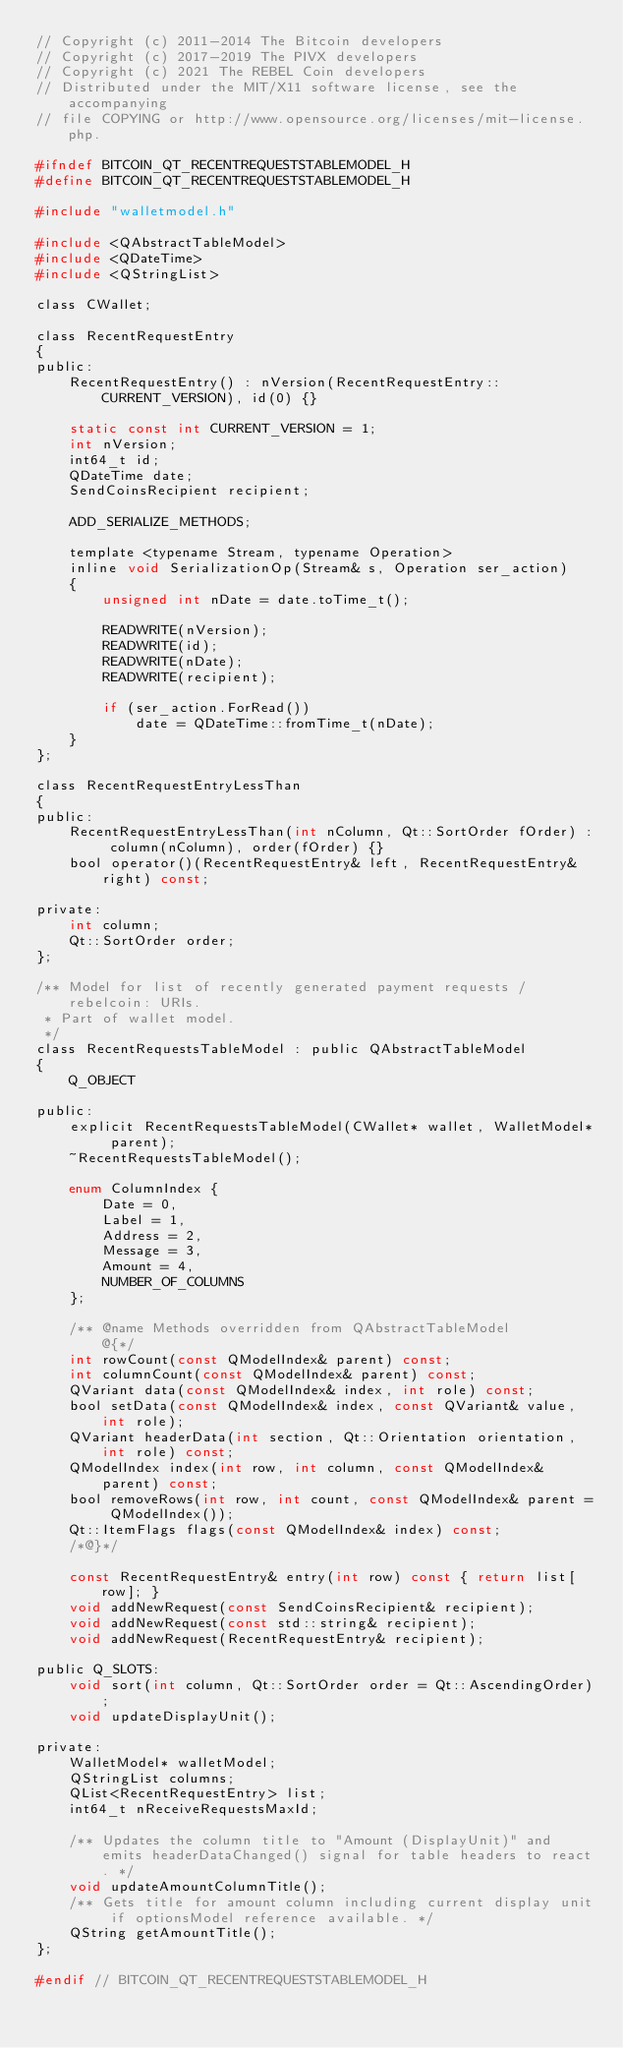Convert code to text. <code><loc_0><loc_0><loc_500><loc_500><_C_>// Copyright (c) 2011-2014 The Bitcoin developers
// Copyright (c) 2017-2019 The PIVX developers
// Copyright (c) 2021 The REBEL Coin developers
// Distributed under the MIT/X11 software license, see the accompanying
// file COPYING or http://www.opensource.org/licenses/mit-license.php.

#ifndef BITCOIN_QT_RECENTREQUESTSTABLEMODEL_H
#define BITCOIN_QT_RECENTREQUESTSTABLEMODEL_H

#include "walletmodel.h"

#include <QAbstractTableModel>
#include <QDateTime>
#include <QStringList>

class CWallet;

class RecentRequestEntry
{
public:
    RecentRequestEntry() : nVersion(RecentRequestEntry::CURRENT_VERSION), id(0) {}

    static const int CURRENT_VERSION = 1;
    int nVersion;
    int64_t id;
    QDateTime date;
    SendCoinsRecipient recipient;

    ADD_SERIALIZE_METHODS;

    template <typename Stream, typename Operation>
    inline void SerializationOp(Stream& s, Operation ser_action)
    {
        unsigned int nDate = date.toTime_t();

        READWRITE(nVersion);
        READWRITE(id);
        READWRITE(nDate);
        READWRITE(recipient);

        if (ser_action.ForRead())
            date = QDateTime::fromTime_t(nDate);
    }
};

class RecentRequestEntryLessThan
{
public:
    RecentRequestEntryLessThan(int nColumn, Qt::SortOrder fOrder) : column(nColumn), order(fOrder) {}
    bool operator()(RecentRequestEntry& left, RecentRequestEntry& right) const;

private:
    int column;
    Qt::SortOrder order;
};

/** Model for list of recently generated payment requests / rebelcoin: URIs.
 * Part of wallet model.
 */
class RecentRequestsTableModel : public QAbstractTableModel
{
    Q_OBJECT

public:
    explicit RecentRequestsTableModel(CWallet* wallet, WalletModel* parent);
    ~RecentRequestsTableModel();

    enum ColumnIndex {
        Date = 0,
        Label = 1,
        Address = 2,
        Message = 3,
        Amount = 4,
        NUMBER_OF_COLUMNS
    };

    /** @name Methods overridden from QAbstractTableModel
        @{*/
    int rowCount(const QModelIndex& parent) const;
    int columnCount(const QModelIndex& parent) const;
    QVariant data(const QModelIndex& index, int role) const;
    bool setData(const QModelIndex& index, const QVariant& value, int role);
    QVariant headerData(int section, Qt::Orientation orientation, int role) const;
    QModelIndex index(int row, int column, const QModelIndex& parent) const;
    bool removeRows(int row, int count, const QModelIndex& parent = QModelIndex());
    Qt::ItemFlags flags(const QModelIndex& index) const;
    /*@}*/

    const RecentRequestEntry& entry(int row) const { return list[row]; }
    void addNewRequest(const SendCoinsRecipient& recipient);
    void addNewRequest(const std::string& recipient);
    void addNewRequest(RecentRequestEntry& recipient);

public Q_SLOTS:
    void sort(int column, Qt::SortOrder order = Qt::AscendingOrder);
    void updateDisplayUnit();

private:
    WalletModel* walletModel;
    QStringList columns;
    QList<RecentRequestEntry> list;
    int64_t nReceiveRequestsMaxId;

    /** Updates the column title to "Amount (DisplayUnit)" and emits headerDataChanged() signal for table headers to react. */
    void updateAmountColumnTitle();
    /** Gets title for amount column including current display unit if optionsModel reference available. */
    QString getAmountTitle();
};

#endif // BITCOIN_QT_RECENTREQUESTSTABLEMODEL_H
</code> 